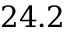Convert formula to latex. <formula><loc_0><loc_0><loc_500><loc_500>2 4 . 2</formula> 